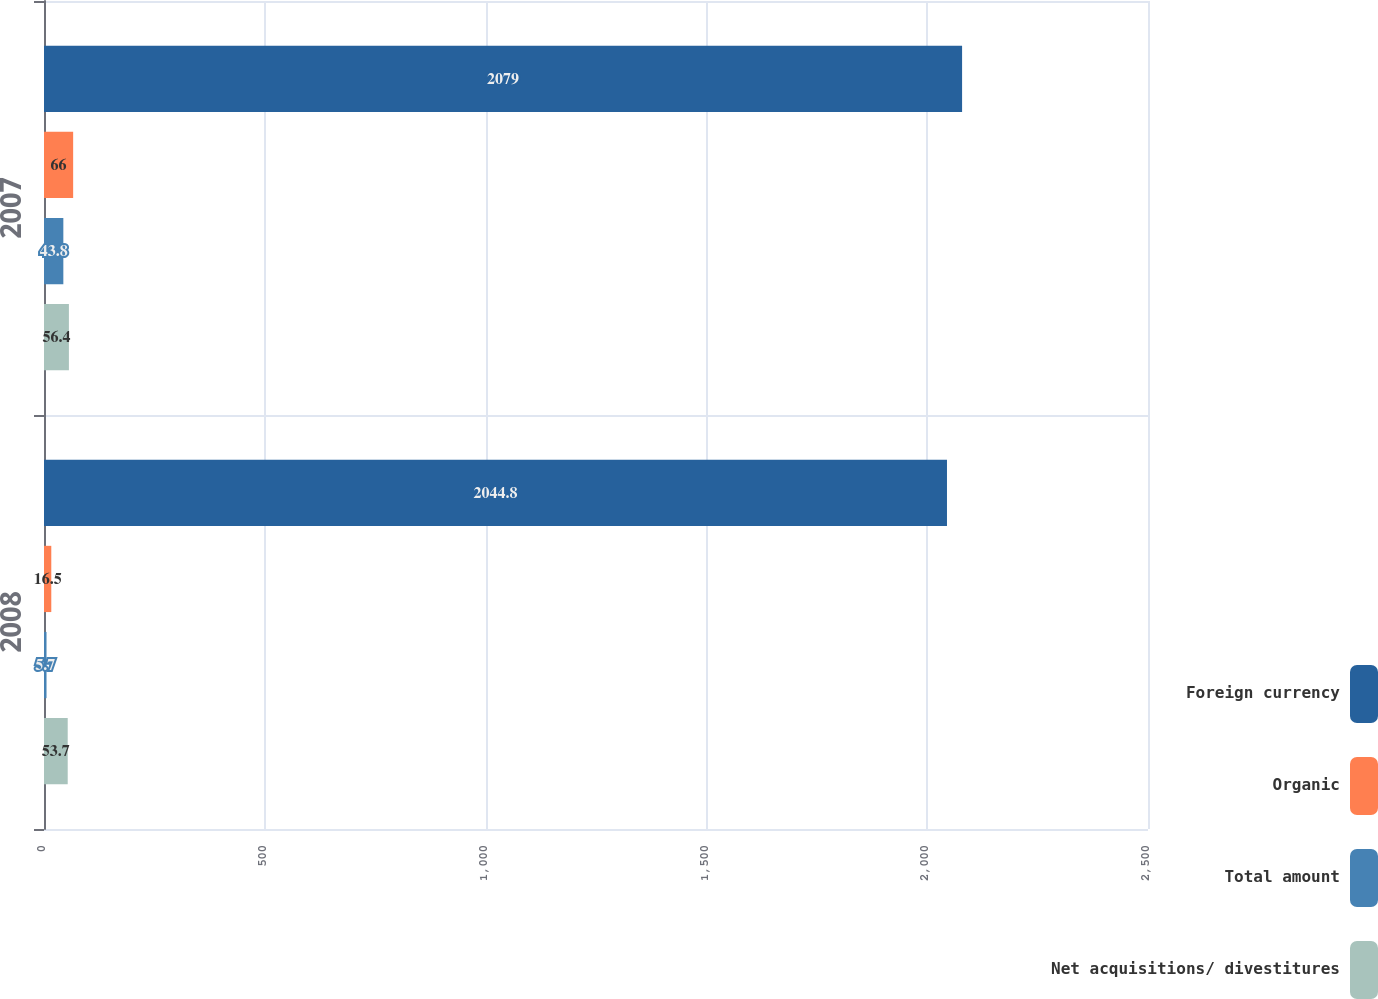<chart> <loc_0><loc_0><loc_500><loc_500><stacked_bar_chart><ecel><fcel>2008<fcel>2007<nl><fcel>Foreign currency<fcel>2044.8<fcel>2079<nl><fcel>Organic<fcel>16.5<fcel>66<nl><fcel>Total amount<fcel>5.7<fcel>43.8<nl><fcel>Net acquisitions/ divestitures<fcel>53.7<fcel>56.4<nl></chart> 